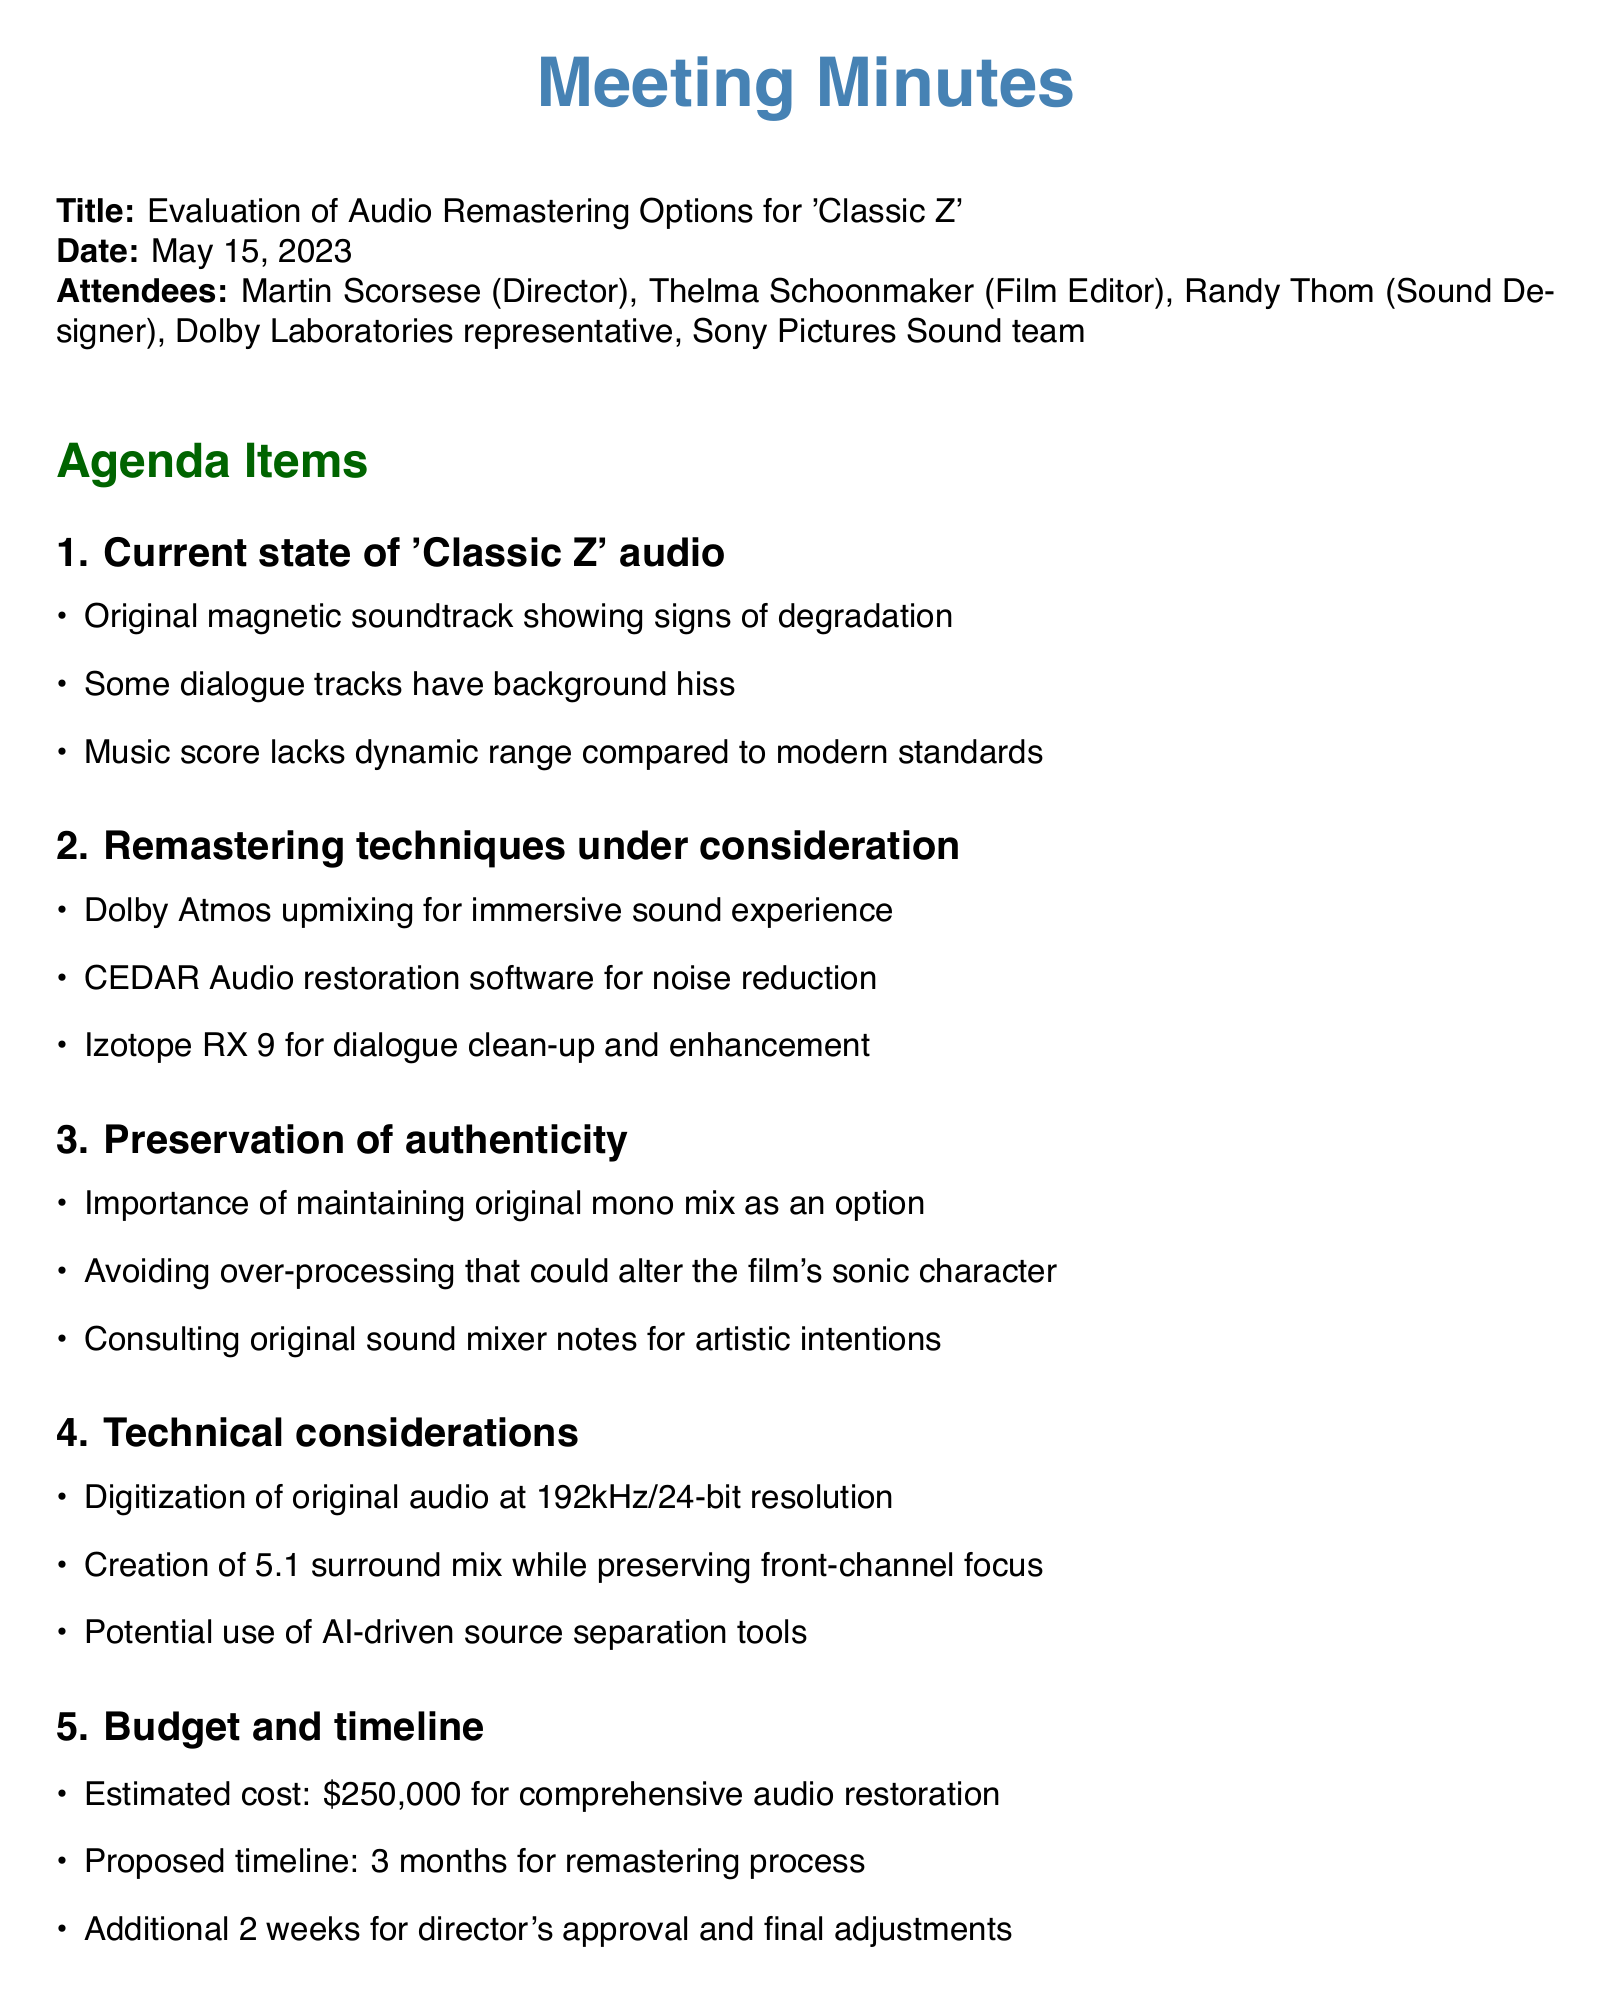what is the title of the meeting? The title of the meeting is explicitly stated at the beginning of the document.
Answer: Evaluation of Audio Remastering Options for 'Classic Z' who are the attendees? The attendees are listed at the beginning of the document.
Answer: Martin Scorsese, Thelma Schoonmaker, Randy Thom, Dolby Laboratories representative, Sony Pictures Sound team what is the estimated cost for audio restoration? The estimated cost is mentioned in the budget section of the document.
Answer: $250,000 what is one of the remastering techniques under consideration? The techniques are outlined in the agenda under remastering options.
Answer: Dolby Atmos upmixing how long is the proposed timeline for the remastering process? The proposed timeline is mentioned in the budget section.
Answer: 3 months why is preserving the original mono mix important? The reason is included in the authenticity section regarding maintaining original elements.
Answer: To maintain sonic character what is one action item from the meeting? The action items are listed at the end, detailing next steps.
Answer: Schedule listening session with original mono mix and test remaster samples which software is being considered for dialogue clean-up? The software for dialogue clean-up is specified in the remastering techniques section.
Answer: Izotope RX 9 what resolution is suggested for digitization of the original audio? The suggested resolution is included in the technical considerations part.
Answer: 192kHz/24-bit 